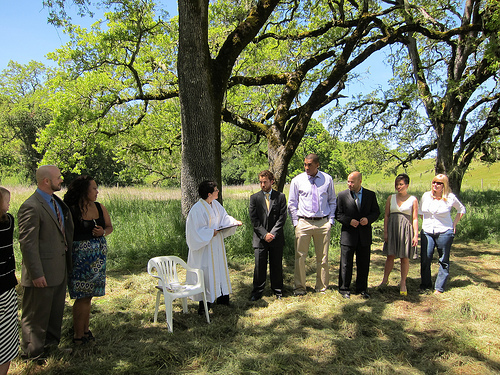<image>
Is there a tree on the chair? No. The tree is not positioned on the chair. They may be near each other, but the tree is not supported by or resting on top of the chair. Is there a man to the left of the woman? Yes. From this viewpoint, the man is positioned to the left side relative to the woman. Is there a chair under the tree? No. The chair is not positioned under the tree. The vertical relationship between these objects is different. Is there a tree behind the woman? Yes. From this viewpoint, the tree is positioned behind the woman, with the woman partially or fully occluding the tree. 